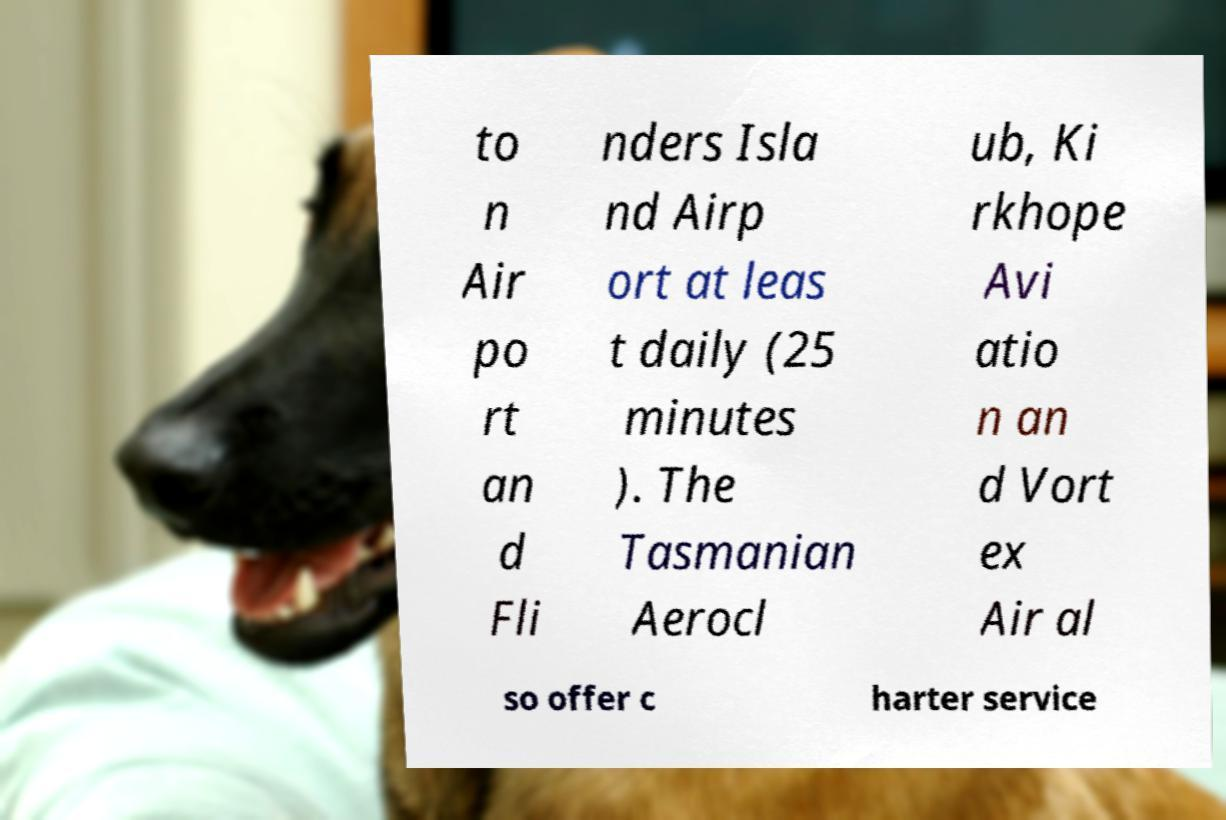What messages or text are displayed in this image? I need them in a readable, typed format. to n Air po rt an d Fli nders Isla nd Airp ort at leas t daily (25 minutes ). The Tasmanian Aerocl ub, Ki rkhope Avi atio n an d Vort ex Air al so offer c harter service 